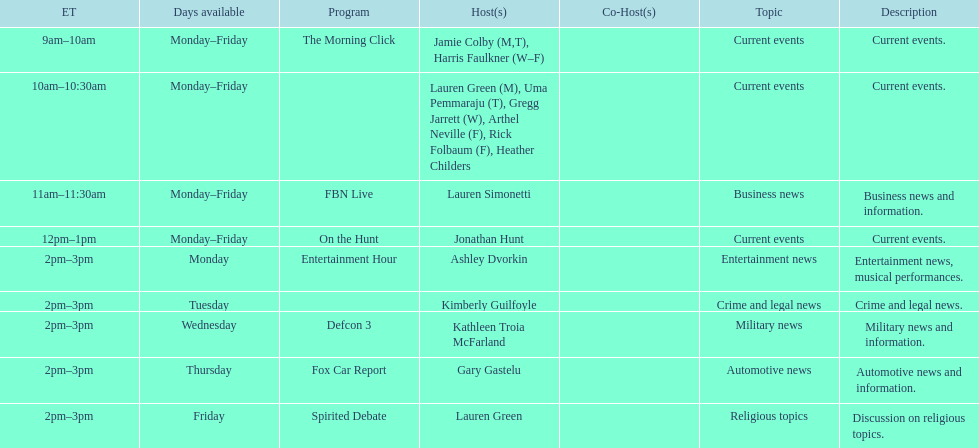How many days is fbn live available each week? 5. 